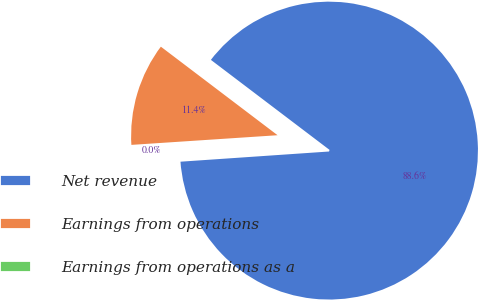Convert chart. <chart><loc_0><loc_0><loc_500><loc_500><pie_chart><fcel>Net revenue<fcel>Earnings from operations<fcel>Earnings from operations as a<nl><fcel>88.58%<fcel>11.38%<fcel>0.04%<nl></chart> 